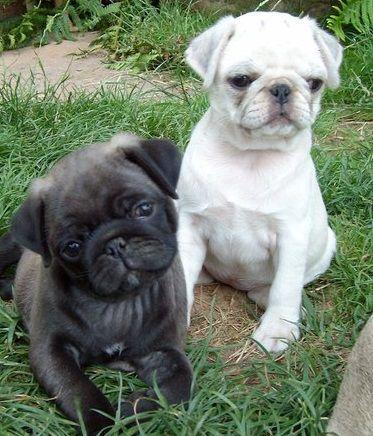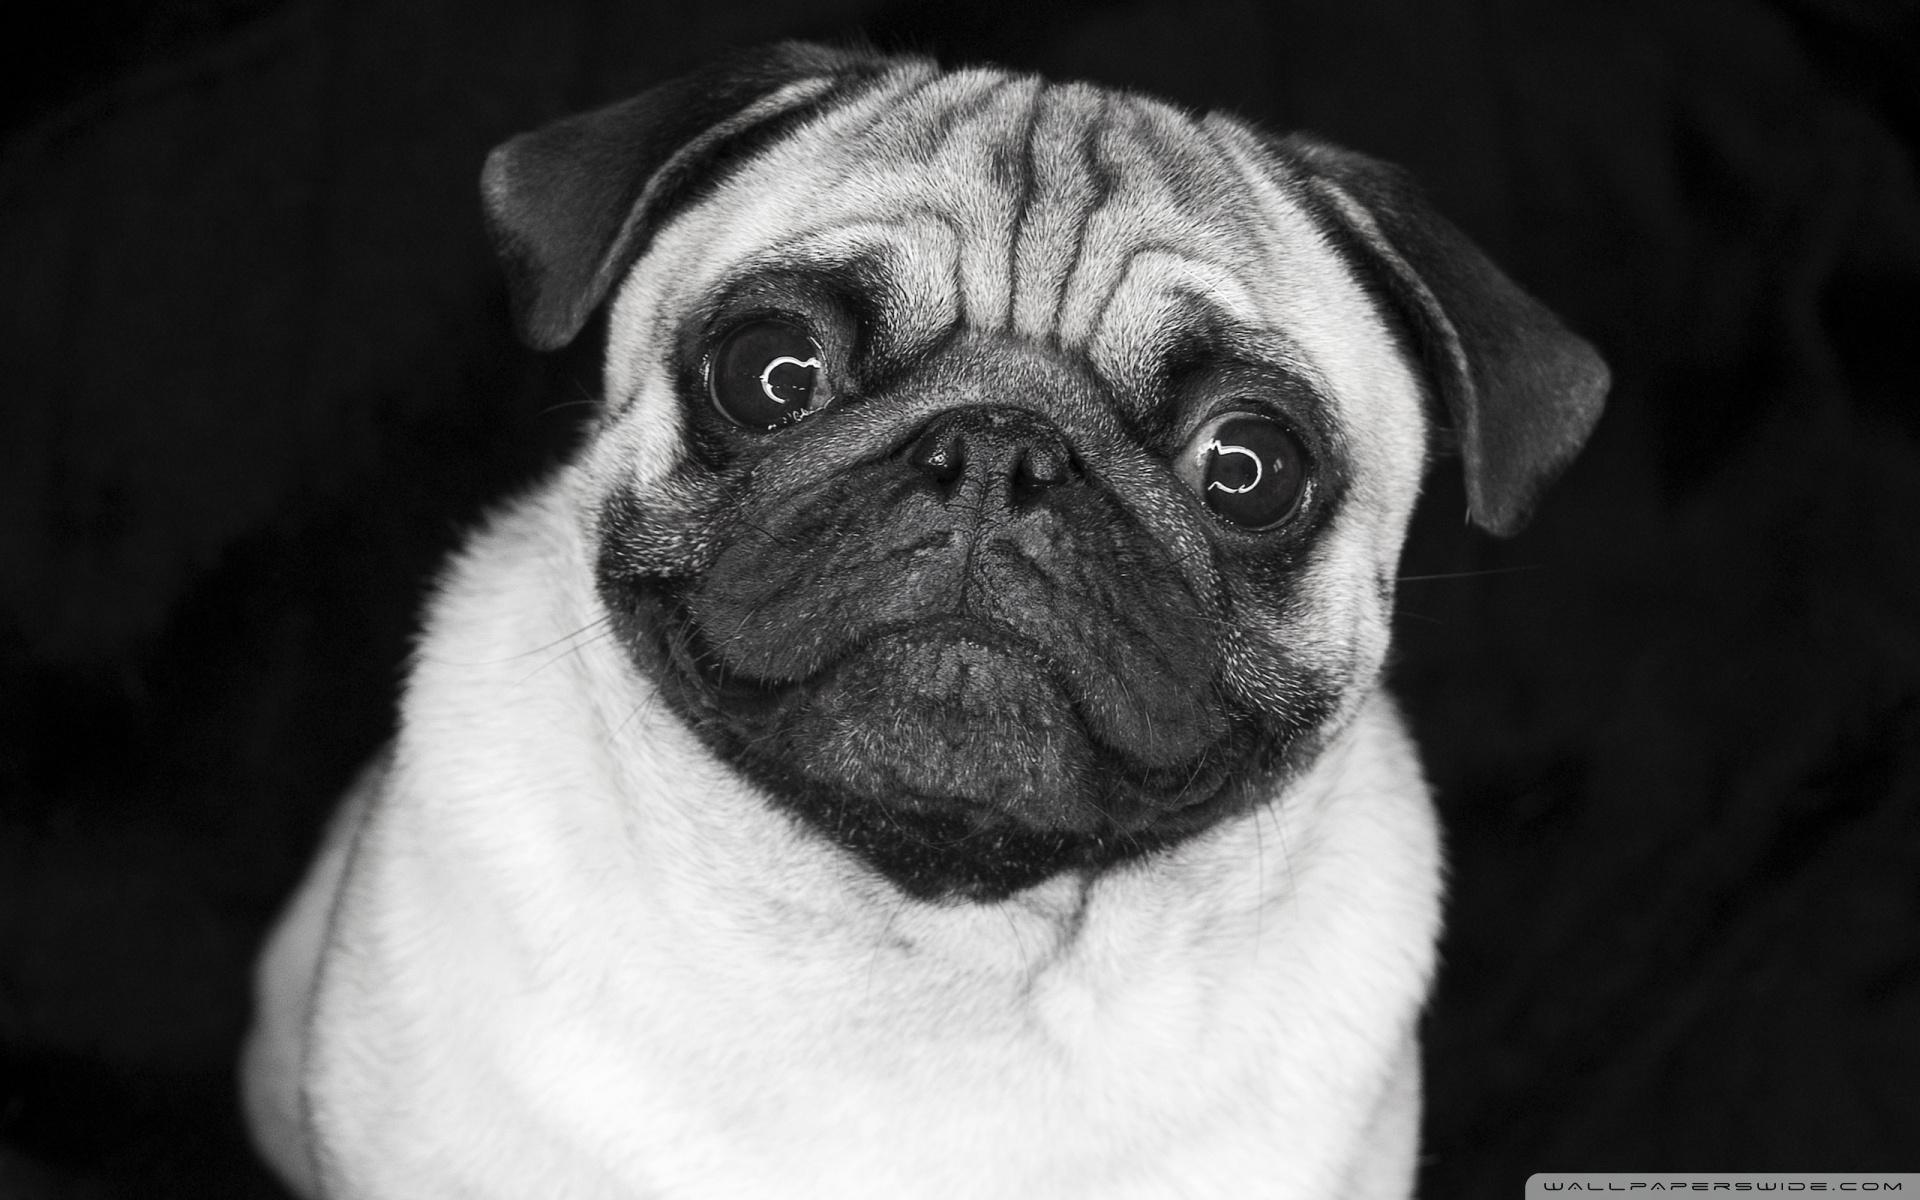The first image is the image on the left, the second image is the image on the right. Analyze the images presented: Is the assertion "Each image contains multiple pugs, and each image includes at least one black pug." valid? Answer yes or no. No. The first image is the image on the left, the second image is the image on the right. Considering the images on both sides, is "There is exactly one light colored dog with a dark muzzle in each image." valid? Answer yes or no. No. 